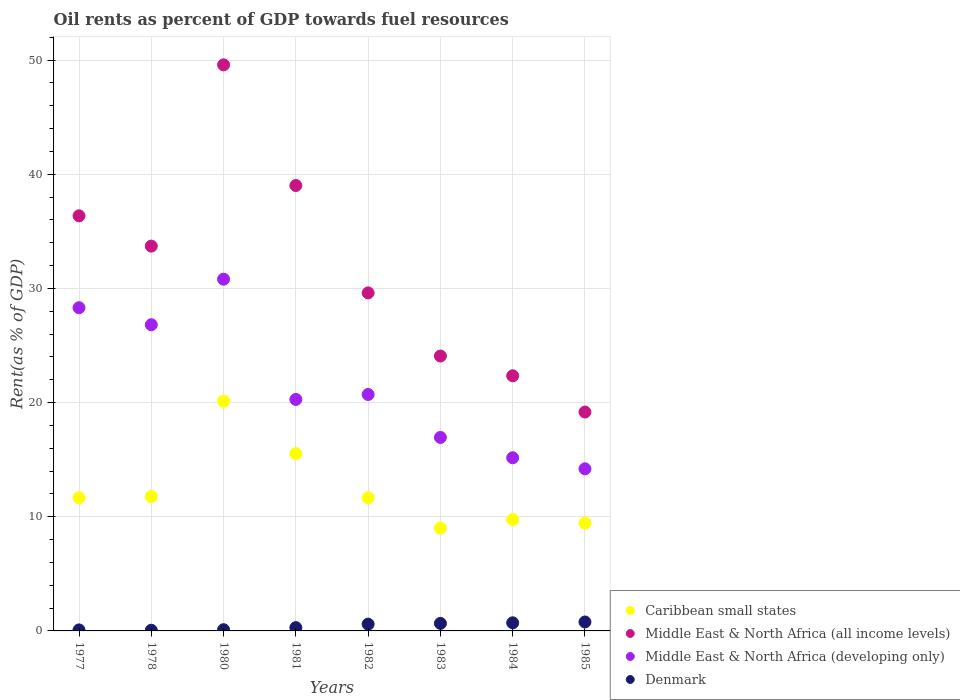Is the number of dotlines equal to the number of legend labels?
Provide a short and direct response. Yes. What is the oil rent in Caribbean small states in 1977?
Your answer should be very brief. 11.67. Across all years, what is the maximum oil rent in Caribbean small states?
Keep it short and to the point. 20.13. Across all years, what is the minimum oil rent in Caribbean small states?
Offer a very short reply. 9.01. In which year was the oil rent in Caribbean small states maximum?
Your answer should be compact. 1980. In which year was the oil rent in Caribbean small states minimum?
Provide a short and direct response. 1983. What is the total oil rent in Denmark in the graph?
Give a very brief answer. 3.29. What is the difference between the oil rent in Denmark in 1983 and that in 1984?
Your response must be concise. -0.05. What is the difference between the oil rent in Middle East & North Africa (developing only) in 1980 and the oil rent in Middle East & North Africa (all income levels) in 1977?
Your answer should be very brief. -5.55. What is the average oil rent in Middle East & North Africa (developing only) per year?
Offer a terse response. 21.66. In the year 1980, what is the difference between the oil rent in Middle East & North Africa (all income levels) and oil rent in Denmark?
Offer a very short reply. 49.48. In how many years, is the oil rent in Middle East & North Africa (all income levels) greater than 10 %?
Provide a short and direct response. 8. What is the ratio of the oil rent in Middle East & North Africa (developing only) in 1978 to that in 1980?
Your answer should be very brief. 0.87. What is the difference between the highest and the second highest oil rent in Middle East & North Africa (all income levels)?
Ensure brevity in your answer.  10.57. What is the difference between the highest and the lowest oil rent in Caribbean small states?
Your answer should be compact. 11.12. Is the sum of the oil rent in Caribbean small states in 1980 and 1984 greater than the maximum oil rent in Middle East & North Africa (all income levels) across all years?
Provide a succinct answer. No. Does the oil rent in Middle East & North Africa (developing only) monotonically increase over the years?
Provide a succinct answer. No. Is the oil rent in Caribbean small states strictly less than the oil rent in Middle East & North Africa (all income levels) over the years?
Provide a short and direct response. Yes. How many dotlines are there?
Give a very brief answer. 4. How many years are there in the graph?
Ensure brevity in your answer.  8. Are the values on the major ticks of Y-axis written in scientific E-notation?
Your response must be concise. No. Does the graph contain grids?
Provide a short and direct response. Yes. How are the legend labels stacked?
Give a very brief answer. Vertical. What is the title of the graph?
Ensure brevity in your answer.  Oil rents as percent of GDP towards fuel resources. Does "Chile" appear as one of the legend labels in the graph?
Your answer should be very brief. No. What is the label or title of the X-axis?
Ensure brevity in your answer.  Years. What is the label or title of the Y-axis?
Your response must be concise. Rent(as % of GDP). What is the Rent(as % of GDP) of Caribbean small states in 1977?
Ensure brevity in your answer.  11.67. What is the Rent(as % of GDP) of Middle East & North Africa (all income levels) in 1977?
Ensure brevity in your answer.  36.36. What is the Rent(as % of GDP) in Middle East & North Africa (developing only) in 1977?
Offer a terse response. 28.31. What is the Rent(as % of GDP) of Denmark in 1977?
Make the answer very short. 0.09. What is the Rent(as % of GDP) in Caribbean small states in 1978?
Offer a very short reply. 11.77. What is the Rent(as % of GDP) of Middle East & North Africa (all income levels) in 1978?
Give a very brief answer. 33.71. What is the Rent(as % of GDP) of Middle East & North Africa (developing only) in 1978?
Give a very brief answer. 26.82. What is the Rent(as % of GDP) in Denmark in 1978?
Give a very brief answer. 0.06. What is the Rent(as % of GDP) in Caribbean small states in 1980?
Ensure brevity in your answer.  20.13. What is the Rent(as % of GDP) of Middle East & North Africa (all income levels) in 1980?
Your answer should be compact. 49.59. What is the Rent(as % of GDP) in Middle East & North Africa (developing only) in 1980?
Provide a short and direct response. 30.81. What is the Rent(as % of GDP) in Denmark in 1980?
Offer a terse response. 0.11. What is the Rent(as % of GDP) of Caribbean small states in 1981?
Give a very brief answer. 15.53. What is the Rent(as % of GDP) of Middle East & North Africa (all income levels) in 1981?
Offer a very short reply. 39.01. What is the Rent(as % of GDP) in Middle East & North Africa (developing only) in 1981?
Provide a short and direct response. 20.28. What is the Rent(as % of GDP) of Denmark in 1981?
Ensure brevity in your answer.  0.29. What is the Rent(as % of GDP) of Caribbean small states in 1982?
Your answer should be compact. 11.66. What is the Rent(as % of GDP) of Middle East & North Africa (all income levels) in 1982?
Provide a short and direct response. 29.61. What is the Rent(as % of GDP) of Middle East & North Africa (developing only) in 1982?
Ensure brevity in your answer.  20.71. What is the Rent(as % of GDP) of Denmark in 1982?
Give a very brief answer. 0.59. What is the Rent(as % of GDP) in Caribbean small states in 1983?
Your answer should be compact. 9.01. What is the Rent(as % of GDP) of Middle East & North Africa (all income levels) in 1983?
Provide a succinct answer. 24.08. What is the Rent(as % of GDP) in Middle East & North Africa (developing only) in 1983?
Provide a short and direct response. 16.95. What is the Rent(as % of GDP) of Denmark in 1983?
Your answer should be very brief. 0.66. What is the Rent(as % of GDP) in Caribbean small states in 1984?
Ensure brevity in your answer.  9.75. What is the Rent(as % of GDP) in Middle East & North Africa (all income levels) in 1984?
Give a very brief answer. 22.35. What is the Rent(as % of GDP) in Middle East & North Africa (developing only) in 1984?
Give a very brief answer. 15.17. What is the Rent(as % of GDP) of Denmark in 1984?
Give a very brief answer. 0.71. What is the Rent(as % of GDP) in Caribbean small states in 1985?
Keep it short and to the point. 9.45. What is the Rent(as % of GDP) of Middle East & North Africa (all income levels) in 1985?
Provide a succinct answer. 19.17. What is the Rent(as % of GDP) in Middle East & North Africa (developing only) in 1985?
Your answer should be compact. 14.2. What is the Rent(as % of GDP) in Denmark in 1985?
Provide a succinct answer. 0.78. Across all years, what is the maximum Rent(as % of GDP) of Caribbean small states?
Provide a succinct answer. 20.13. Across all years, what is the maximum Rent(as % of GDP) of Middle East & North Africa (all income levels)?
Your answer should be compact. 49.59. Across all years, what is the maximum Rent(as % of GDP) of Middle East & North Africa (developing only)?
Offer a very short reply. 30.81. Across all years, what is the maximum Rent(as % of GDP) of Denmark?
Make the answer very short. 0.78. Across all years, what is the minimum Rent(as % of GDP) of Caribbean small states?
Offer a terse response. 9.01. Across all years, what is the minimum Rent(as % of GDP) in Middle East & North Africa (all income levels)?
Provide a short and direct response. 19.17. Across all years, what is the minimum Rent(as % of GDP) in Middle East & North Africa (developing only)?
Your response must be concise. 14.2. Across all years, what is the minimum Rent(as % of GDP) in Denmark?
Your response must be concise. 0.06. What is the total Rent(as % of GDP) of Caribbean small states in the graph?
Give a very brief answer. 98.97. What is the total Rent(as % of GDP) in Middle East & North Africa (all income levels) in the graph?
Your answer should be compact. 253.88. What is the total Rent(as % of GDP) in Middle East & North Africa (developing only) in the graph?
Offer a terse response. 173.25. What is the total Rent(as % of GDP) of Denmark in the graph?
Provide a succinct answer. 3.29. What is the difference between the Rent(as % of GDP) of Caribbean small states in 1977 and that in 1978?
Keep it short and to the point. -0.1. What is the difference between the Rent(as % of GDP) of Middle East & North Africa (all income levels) in 1977 and that in 1978?
Offer a terse response. 2.65. What is the difference between the Rent(as % of GDP) of Middle East & North Africa (developing only) in 1977 and that in 1978?
Ensure brevity in your answer.  1.49. What is the difference between the Rent(as % of GDP) in Denmark in 1977 and that in 1978?
Provide a succinct answer. 0.03. What is the difference between the Rent(as % of GDP) in Caribbean small states in 1977 and that in 1980?
Offer a terse response. -8.46. What is the difference between the Rent(as % of GDP) in Middle East & North Africa (all income levels) in 1977 and that in 1980?
Keep it short and to the point. -13.22. What is the difference between the Rent(as % of GDP) of Middle East & North Africa (developing only) in 1977 and that in 1980?
Ensure brevity in your answer.  -2.5. What is the difference between the Rent(as % of GDP) of Denmark in 1977 and that in 1980?
Offer a terse response. -0.02. What is the difference between the Rent(as % of GDP) of Caribbean small states in 1977 and that in 1981?
Your answer should be compact. -3.86. What is the difference between the Rent(as % of GDP) of Middle East & North Africa (all income levels) in 1977 and that in 1981?
Offer a very short reply. -2.65. What is the difference between the Rent(as % of GDP) of Middle East & North Africa (developing only) in 1977 and that in 1981?
Make the answer very short. 8.03. What is the difference between the Rent(as % of GDP) in Denmark in 1977 and that in 1981?
Offer a very short reply. -0.2. What is the difference between the Rent(as % of GDP) of Middle East & North Africa (all income levels) in 1977 and that in 1982?
Provide a succinct answer. 6.75. What is the difference between the Rent(as % of GDP) of Middle East & North Africa (developing only) in 1977 and that in 1982?
Give a very brief answer. 7.6. What is the difference between the Rent(as % of GDP) in Denmark in 1977 and that in 1982?
Keep it short and to the point. -0.51. What is the difference between the Rent(as % of GDP) in Caribbean small states in 1977 and that in 1983?
Provide a short and direct response. 2.66. What is the difference between the Rent(as % of GDP) in Middle East & North Africa (all income levels) in 1977 and that in 1983?
Your response must be concise. 12.28. What is the difference between the Rent(as % of GDP) of Middle East & North Africa (developing only) in 1977 and that in 1983?
Provide a succinct answer. 11.36. What is the difference between the Rent(as % of GDP) in Denmark in 1977 and that in 1983?
Your answer should be very brief. -0.57. What is the difference between the Rent(as % of GDP) in Caribbean small states in 1977 and that in 1984?
Keep it short and to the point. 1.92. What is the difference between the Rent(as % of GDP) of Middle East & North Africa (all income levels) in 1977 and that in 1984?
Offer a terse response. 14.01. What is the difference between the Rent(as % of GDP) in Middle East & North Africa (developing only) in 1977 and that in 1984?
Offer a terse response. 13.14. What is the difference between the Rent(as % of GDP) in Denmark in 1977 and that in 1984?
Provide a succinct answer. -0.62. What is the difference between the Rent(as % of GDP) of Caribbean small states in 1977 and that in 1985?
Give a very brief answer. 2.22. What is the difference between the Rent(as % of GDP) in Middle East & North Africa (all income levels) in 1977 and that in 1985?
Offer a terse response. 17.19. What is the difference between the Rent(as % of GDP) in Middle East & North Africa (developing only) in 1977 and that in 1985?
Your answer should be very brief. 14.11. What is the difference between the Rent(as % of GDP) of Denmark in 1977 and that in 1985?
Keep it short and to the point. -0.69. What is the difference between the Rent(as % of GDP) in Caribbean small states in 1978 and that in 1980?
Your answer should be very brief. -8.35. What is the difference between the Rent(as % of GDP) of Middle East & North Africa (all income levels) in 1978 and that in 1980?
Provide a succinct answer. -15.88. What is the difference between the Rent(as % of GDP) of Middle East & North Africa (developing only) in 1978 and that in 1980?
Provide a short and direct response. -3.99. What is the difference between the Rent(as % of GDP) of Denmark in 1978 and that in 1980?
Give a very brief answer. -0.05. What is the difference between the Rent(as % of GDP) in Caribbean small states in 1978 and that in 1981?
Keep it short and to the point. -3.75. What is the difference between the Rent(as % of GDP) of Middle East & North Africa (all income levels) in 1978 and that in 1981?
Offer a very short reply. -5.31. What is the difference between the Rent(as % of GDP) of Middle East & North Africa (developing only) in 1978 and that in 1981?
Make the answer very short. 6.54. What is the difference between the Rent(as % of GDP) of Denmark in 1978 and that in 1981?
Offer a very short reply. -0.23. What is the difference between the Rent(as % of GDP) in Caribbean small states in 1978 and that in 1982?
Make the answer very short. 0.11. What is the difference between the Rent(as % of GDP) of Middle East & North Africa (all income levels) in 1978 and that in 1982?
Your answer should be compact. 4.1. What is the difference between the Rent(as % of GDP) of Middle East & North Africa (developing only) in 1978 and that in 1982?
Provide a short and direct response. 6.11. What is the difference between the Rent(as % of GDP) in Denmark in 1978 and that in 1982?
Provide a succinct answer. -0.53. What is the difference between the Rent(as % of GDP) of Caribbean small states in 1978 and that in 1983?
Offer a very short reply. 2.77. What is the difference between the Rent(as % of GDP) of Middle East & North Africa (all income levels) in 1978 and that in 1983?
Give a very brief answer. 9.63. What is the difference between the Rent(as % of GDP) of Middle East & North Africa (developing only) in 1978 and that in 1983?
Provide a short and direct response. 9.87. What is the difference between the Rent(as % of GDP) in Denmark in 1978 and that in 1983?
Your answer should be compact. -0.6. What is the difference between the Rent(as % of GDP) of Caribbean small states in 1978 and that in 1984?
Your answer should be compact. 2.02. What is the difference between the Rent(as % of GDP) of Middle East & North Africa (all income levels) in 1978 and that in 1984?
Ensure brevity in your answer.  11.36. What is the difference between the Rent(as % of GDP) of Middle East & North Africa (developing only) in 1978 and that in 1984?
Provide a succinct answer. 11.65. What is the difference between the Rent(as % of GDP) of Denmark in 1978 and that in 1984?
Your answer should be compact. -0.65. What is the difference between the Rent(as % of GDP) of Caribbean small states in 1978 and that in 1985?
Provide a short and direct response. 2.33. What is the difference between the Rent(as % of GDP) of Middle East & North Africa (all income levels) in 1978 and that in 1985?
Ensure brevity in your answer.  14.53. What is the difference between the Rent(as % of GDP) in Middle East & North Africa (developing only) in 1978 and that in 1985?
Your answer should be compact. 12.62. What is the difference between the Rent(as % of GDP) of Denmark in 1978 and that in 1985?
Offer a very short reply. -0.72. What is the difference between the Rent(as % of GDP) in Caribbean small states in 1980 and that in 1981?
Keep it short and to the point. 4.6. What is the difference between the Rent(as % of GDP) in Middle East & North Africa (all income levels) in 1980 and that in 1981?
Offer a terse response. 10.57. What is the difference between the Rent(as % of GDP) in Middle East & North Africa (developing only) in 1980 and that in 1981?
Give a very brief answer. 10.53. What is the difference between the Rent(as % of GDP) in Denmark in 1980 and that in 1981?
Your answer should be very brief. -0.18. What is the difference between the Rent(as % of GDP) in Caribbean small states in 1980 and that in 1982?
Provide a succinct answer. 8.47. What is the difference between the Rent(as % of GDP) of Middle East & North Africa (all income levels) in 1980 and that in 1982?
Give a very brief answer. 19.98. What is the difference between the Rent(as % of GDP) of Middle East & North Africa (developing only) in 1980 and that in 1982?
Make the answer very short. 10.1. What is the difference between the Rent(as % of GDP) in Denmark in 1980 and that in 1982?
Your answer should be very brief. -0.49. What is the difference between the Rent(as % of GDP) in Caribbean small states in 1980 and that in 1983?
Give a very brief answer. 11.12. What is the difference between the Rent(as % of GDP) of Middle East & North Africa (all income levels) in 1980 and that in 1983?
Provide a succinct answer. 25.51. What is the difference between the Rent(as % of GDP) of Middle East & North Africa (developing only) in 1980 and that in 1983?
Offer a very short reply. 13.86. What is the difference between the Rent(as % of GDP) in Denmark in 1980 and that in 1983?
Offer a very short reply. -0.55. What is the difference between the Rent(as % of GDP) in Caribbean small states in 1980 and that in 1984?
Make the answer very short. 10.38. What is the difference between the Rent(as % of GDP) of Middle East & North Africa (all income levels) in 1980 and that in 1984?
Keep it short and to the point. 27.24. What is the difference between the Rent(as % of GDP) of Middle East & North Africa (developing only) in 1980 and that in 1984?
Make the answer very short. 15.64. What is the difference between the Rent(as % of GDP) of Denmark in 1980 and that in 1984?
Your answer should be compact. -0.6. What is the difference between the Rent(as % of GDP) in Caribbean small states in 1980 and that in 1985?
Give a very brief answer. 10.68. What is the difference between the Rent(as % of GDP) in Middle East & North Africa (all income levels) in 1980 and that in 1985?
Give a very brief answer. 30.41. What is the difference between the Rent(as % of GDP) of Middle East & North Africa (developing only) in 1980 and that in 1985?
Your answer should be compact. 16.61. What is the difference between the Rent(as % of GDP) in Denmark in 1980 and that in 1985?
Keep it short and to the point. -0.68. What is the difference between the Rent(as % of GDP) of Caribbean small states in 1981 and that in 1982?
Your answer should be very brief. 3.87. What is the difference between the Rent(as % of GDP) of Middle East & North Africa (all income levels) in 1981 and that in 1982?
Make the answer very short. 9.4. What is the difference between the Rent(as % of GDP) of Middle East & North Africa (developing only) in 1981 and that in 1982?
Provide a short and direct response. -0.43. What is the difference between the Rent(as % of GDP) in Denmark in 1981 and that in 1982?
Provide a succinct answer. -0.3. What is the difference between the Rent(as % of GDP) in Caribbean small states in 1981 and that in 1983?
Offer a terse response. 6.52. What is the difference between the Rent(as % of GDP) in Middle East & North Africa (all income levels) in 1981 and that in 1983?
Your answer should be compact. 14.93. What is the difference between the Rent(as % of GDP) of Middle East & North Africa (developing only) in 1981 and that in 1983?
Give a very brief answer. 3.33. What is the difference between the Rent(as % of GDP) in Denmark in 1981 and that in 1983?
Keep it short and to the point. -0.37. What is the difference between the Rent(as % of GDP) in Caribbean small states in 1981 and that in 1984?
Keep it short and to the point. 5.77. What is the difference between the Rent(as % of GDP) in Middle East & North Africa (all income levels) in 1981 and that in 1984?
Provide a succinct answer. 16.67. What is the difference between the Rent(as % of GDP) of Middle East & North Africa (developing only) in 1981 and that in 1984?
Provide a succinct answer. 5.11. What is the difference between the Rent(as % of GDP) of Denmark in 1981 and that in 1984?
Keep it short and to the point. -0.42. What is the difference between the Rent(as % of GDP) in Caribbean small states in 1981 and that in 1985?
Give a very brief answer. 6.08. What is the difference between the Rent(as % of GDP) of Middle East & North Africa (all income levels) in 1981 and that in 1985?
Ensure brevity in your answer.  19.84. What is the difference between the Rent(as % of GDP) of Middle East & North Africa (developing only) in 1981 and that in 1985?
Your response must be concise. 6.08. What is the difference between the Rent(as % of GDP) in Denmark in 1981 and that in 1985?
Your answer should be very brief. -0.49. What is the difference between the Rent(as % of GDP) in Caribbean small states in 1982 and that in 1983?
Offer a very short reply. 2.65. What is the difference between the Rent(as % of GDP) in Middle East & North Africa (all income levels) in 1982 and that in 1983?
Ensure brevity in your answer.  5.53. What is the difference between the Rent(as % of GDP) of Middle East & North Africa (developing only) in 1982 and that in 1983?
Keep it short and to the point. 3.76. What is the difference between the Rent(as % of GDP) of Denmark in 1982 and that in 1983?
Give a very brief answer. -0.07. What is the difference between the Rent(as % of GDP) of Caribbean small states in 1982 and that in 1984?
Keep it short and to the point. 1.91. What is the difference between the Rent(as % of GDP) of Middle East & North Africa (all income levels) in 1982 and that in 1984?
Ensure brevity in your answer.  7.26. What is the difference between the Rent(as % of GDP) of Middle East & North Africa (developing only) in 1982 and that in 1984?
Ensure brevity in your answer.  5.54. What is the difference between the Rent(as % of GDP) of Denmark in 1982 and that in 1984?
Ensure brevity in your answer.  -0.12. What is the difference between the Rent(as % of GDP) of Caribbean small states in 1982 and that in 1985?
Ensure brevity in your answer.  2.21. What is the difference between the Rent(as % of GDP) of Middle East & North Africa (all income levels) in 1982 and that in 1985?
Ensure brevity in your answer.  10.44. What is the difference between the Rent(as % of GDP) of Middle East & North Africa (developing only) in 1982 and that in 1985?
Your answer should be very brief. 6.51. What is the difference between the Rent(as % of GDP) of Denmark in 1982 and that in 1985?
Keep it short and to the point. -0.19. What is the difference between the Rent(as % of GDP) of Caribbean small states in 1983 and that in 1984?
Your response must be concise. -0.75. What is the difference between the Rent(as % of GDP) in Middle East & North Africa (all income levels) in 1983 and that in 1984?
Your response must be concise. 1.73. What is the difference between the Rent(as % of GDP) of Middle East & North Africa (developing only) in 1983 and that in 1984?
Offer a very short reply. 1.78. What is the difference between the Rent(as % of GDP) in Denmark in 1983 and that in 1984?
Make the answer very short. -0.05. What is the difference between the Rent(as % of GDP) in Caribbean small states in 1983 and that in 1985?
Provide a succinct answer. -0.44. What is the difference between the Rent(as % of GDP) of Middle East & North Africa (all income levels) in 1983 and that in 1985?
Keep it short and to the point. 4.91. What is the difference between the Rent(as % of GDP) in Middle East & North Africa (developing only) in 1983 and that in 1985?
Your answer should be very brief. 2.75. What is the difference between the Rent(as % of GDP) in Denmark in 1983 and that in 1985?
Offer a very short reply. -0.12. What is the difference between the Rent(as % of GDP) of Caribbean small states in 1984 and that in 1985?
Keep it short and to the point. 0.31. What is the difference between the Rent(as % of GDP) in Middle East & North Africa (all income levels) in 1984 and that in 1985?
Give a very brief answer. 3.18. What is the difference between the Rent(as % of GDP) of Middle East & North Africa (developing only) in 1984 and that in 1985?
Offer a terse response. 0.97. What is the difference between the Rent(as % of GDP) of Denmark in 1984 and that in 1985?
Keep it short and to the point. -0.07. What is the difference between the Rent(as % of GDP) of Caribbean small states in 1977 and the Rent(as % of GDP) of Middle East & North Africa (all income levels) in 1978?
Provide a short and direct response. -22.04. What is the difference between the Rent(as % of GDP) in Caribbean small states in 1977 and the Rent(as % of GDP) in Middle East & North Africa (developing only) in 1978?
Keep it short and to the point. -15.15. What is the difference between the Rent(as % of GDP) of Caribbean small states in 1977 and the Rent(as % of GDP) of Denmark in 1978?
Keep it short and to the point. 11.61. What is the difference between the Rent(as % of GDP) of Middle East & North Africa (all income levels) in 1977 and the Rent(as % of GDP) of Middle East & North Africa (developing only) in 1978?
Provide a succinct answer. 9.54. What is the difference between the Rent(as % of GDP) in Middle East & North Africa (all income levels) in 1977 and the Rent(as % of GDP) in Denmark in 1978?
Make the answer very short. 36.3. What is the difference between the Rent(as % of GDP) of Middle East & North Africa (developing only) in 1977 and the Rent(as % of GDP) of Denmark in 1978?
Ensure brevity in your answer.  28.25. What is the difference between the Rent(as % of GDP) of Caribbean small states in 1977 and the Rent(as % of GDP) of Middle East & North Africa (all income levels) in 1980?
Your answer should be compact. -37.92. What is the difference between the Rent(as % of GDP) of Caribbean small states in 1977 and the Rent(as % of GDP) of Middle East & North Africa (developing only) in 1980?
Offer a terse response. -19.14. What is the difference between the Rent(as % of GDP) of Caribbean small states in 1977 and the Rent(as % of GDP) of Denmark in 1980?
Keep it short and to the point. 11.56. What is the difference between the Rent(as % of GDP) in Middle East & North Africa (all income levels) in 1977 and the Rent(as % of GDP) in Middle East & North Africa (developing only) in 1980?
Your response must be concise. 5.55. What is the difference between the Rent(as % of GDP) in Middle East & North Africa (all income levels) in 1977 and the Rent(as % of GDP) in Denmark in 1980?
Give a very brief answer. 36.25. What is the difference between the Rent(as % of GDP) of Middle East & North Africa (developing only) in 1977 and the Rent(as % of GDP) of Denmark in 1980?
Your answer should be very brief. 28.2. What is the difference between the Rent(as % of GDP) of Caribbean small states in 1977 and the Rent(as % of GDP) of Middle East & North Africa (all income levels) in 1981?
Your response must be concise. -27.34. What is the difference between the Rent(as % of GDP) in Caribbean small states in 1977 and the Rent(as % of GDP) in Middle East & North Africa (developing only) in 1981?
Your answer should be very brief. -8.61. What is the difference between the Rent(as % of GDP) in Caribbean small states in 1977 and the Rent(as % of GDP) in Denmark in 1981?
Offer a very short reply. 11.38. What is the difference between the Rent(as % of GDP) in Middle East & North Africa (all income levels) in 1977 and the Rent(as % of GDP) in Middle East & North Africa (developing only) in 1981?
Your response must be concise. 16.08. What is the difference between the Rent(as % of GDP) in Middle East & North Africa (all income levels) in 1977 and the Rent(as % of GDP) in Denmark in 1981?
Offer a terse response. 36.07. What is the difference between the Rent(as % of GDP) in Middle East & North Africa (developing only) in 1977 and the Rent(as % of GDP) in Denmark in 1981?
Provide a short and direct response. 28.02. What is the difference between the Rent(as % of GDP) of Caribbean small states in 1977 and the Rent(as % of GDP) of Middle East & North Africa (all income levels) in 1982?
Provide a short and direct response. -17.94. What is the difference between the Rent(as % of GDP) in Caribbean small states in 1977 and the Rent(as % of GDP) in Middle East & North Africa (developing only) in 1982?
Keep it short and to the point. -9.04. What is the difference between the Rent(as % of GDP) of Caribbean small states in 1977 and the Rent(as % of GDP) of Denmark in 1982?
Make the answer very short. 11.08. What is the difference between the Rent(as % of GDP) in Middle East & North Africa (all income levels) in 1977 and the Rent(as % of GDP) in Middle East & North Africa (developing only) in 1982?
Offer a terse response. 15.65. What is the difference between the Rent(as % of GDP) in Middle East & North Africa (all income levels) in 1977 and the Rent(as % of GDP) in Denmark in 1982?
Your answer should be very brief. 35.77. What is the difference between the Rent(as % of GDP) in Middle East & North Africa (developing only) in 1977 and the Rent(as % of GDP) in Denmark in 1982?
Your answer should be compact. 27.72. What is the difference between the Rent(as % of GDP) in Caribbean small states in 1977 and the Rent(as % of GDP) in Middle East & North Africa (all income levels) in 1983?
Keep it short and to the point. -12.41. What is the difference between the Rent(as % of GDP) of Caribbean small states in 1977 and the Rent(as % of GDP) of Middle East & North Africa (developing only) in 1983?
Ensure brevity in your answer.  -5.28. What is the difference between the Rent(as % of GDP) in Caribbean small states in 1977 and the Rent(as % of GDP) in Denmark in 1983?
Your answer should be compact. 11.01. What is the difference between the Rent(as % of GDP) of Middle East & North Africa (all income levels) in 1977 and the Rent(as % of GDP) of Middle East & North Africa (developing only) in 1983?
Provide a short and direct response. 19.41. What is the difference between the Rent(as % of GDP) of Middle East & North Africa (all income levels) in 1977 and the Rent(as % of GDP) of Denmark in 1983?
Provide a succinct answer. 35.7. What is the difference between the Rent(as % of GDP) in Middle East & North Africa (developing only) in 1977 and the Rent(as % of GDP) in Denmark in 1983?
Your answer should be compact. 27.65. What is the difference between the Rent(as % of GDP) in Caribbean small states in 1977 and the Rent(as % of GDP) in Middle East & North Africa (all income levels) in 1984?
Your answer should be compact. -10.68. What is the difference between the Rent(as % of GDP) in Caribbean small states in 1977 and the Rent(as % of GDP) in Middle East & North Africa (developing only) in 1984?
Provide a succinct answer. -3.5. What is the difference between the Rent(as % of GDP) in Caribbean small states in 1977 and the Rent(as % of GDP) in Denmark in 1984?
Provide a short and direct response. 10.96. What is the difference between the Rent(as % of GDP) of Middle East & North Africa (all income levels) in 1977 and the Rent(as % of GDP) of Middle East & North Africa (developing only) in 1984?
Offer a terse response. 21.19. What is the difference between the Rent(as % of GDP) of Middle East & North Africa (all income levels) in 1977 and the Rent(as % of GDP) of Denmark in 1984?
Give a very brief answer. 35.65. What is the difference between the Rent(as % of GDP) of Middle East & North Africa (developing only) in 1977 and the Rent(as % of GDP) of Denmark in 1984?
Offer a terse response. 27.6. What is the difference between the Rent(as % of GDP) of Caribbean small states in 1977 and the Rent(as % of GDP) of Middle East & North Africa (all income levels) in 1985?
Provide a succinct answer. -7.5. What is the difference between the Rent(as % of GDP) of Caribbean small states in 1977 and the Rent(as % of GDP) of Middle East & North Africa (developing only) in 1985?
Your answer should be very brief. -2.53. What is the difference between the Rent(as % of GDP) of Caribbean small states in 1977 and the Rent(as % of GDP) of Denmark in 1985?
Provide a short and direct response. 10.89. What is the difference between the Rent(as % of GDP) of Middle East & North Africa (all income levels) in 1977 and the Rent(as % of GDP) of Middle East & North Africa (developing only) in 1985?
Give a very brief answer. 22.16. What is the difference between the Rent(as % of GDP) in Middle East & North Africa (all income levels) in 1977 and the Rent(as % of GDP) in Denmark in 1985?
Keep it short and to the point. 35.58. What is the difference between the Rent(as % of GDP) in Middle East & North Africa (developing only) in 1977 and the Rent(as % of GDP) in Denmark in 1985?
Offer a very short reply. 27.53. What is the difference between the Rent(as % of GDP) in Caribbean small states in 1978 and the Rent(as % of GDP) in Middle East & North Africa (all income levels) in 1980?
Give a very brief answer. -37.81. What is the difference between the Rent(as % of GDP) of Caribbean small states in 1978 and the Rent(as % of GDP) of Middle East & North Africa (developing only) in 1980?
Offer a very short reply. -19.04. What is the difference between the Rent(as % of GDP) of Caribbean small states in 1978 and the Rent(as % of GDP) of Denmark in 1980?
Your answer should be compact. 11.67. What is the difference between the Rent(as % of GDP) in Middle East & North Africa (all income levels) in 1978 and the Rent(as % of GDP) in Middle East & North Africa (developing only) in 1980?
Your answer should be compact. 2.9. What is the difference between the Rent(as % of GDP) of Middle East & North Africa (all income levels) in 1978 and the Rent(as % of GDP) of Denmark in 1980?
Your answer should be compact. 33.6. What is the difference between the Rent(as % of GDP) in Middle East & North Africa (developing only) in 1978 and the Rent(as % of GDP) in Denmark in 1980?
Keep it short and to the point. 26.71. What is the difference between the Rent(as % of GDP) of Caribbean small states in 1978 and the Rent(as % of GDP) of Middle East & North Africa (all income levels) in 1981?
Provide a succinct answer. -27.24. What is the difference between the Rent(as % of GDP) in Caribbean small states in 1978 and the Rent(as % of GDP) in Middle East & North Africa (developing only) in 1981?
Offer a terse response. -8.5. What is the difference between the Rent(as % of GDP) in Caribbean small states in 1978 and the Rent(as % of GDP) in Denmark in 1981?
Offer a very short reply. 11.49. What is the difference between the Rent(as % of GDP) of Middle East & North Africa (all income levels) in 1978 and the Rent(as % of GDP) of Middle East & North Africa (developing only) in 1981?
Make the answer very short. 13.43. What is the difference between the Rent(as % of GDP) in Middle East & North Africa (all income levels) in 1978 and the Rent(as % of GDP) in Denmark in 1981?
Make the answer very short. 33.42. What is the difference between the Rent(as % of GDP) of Middle East & North Africa (developing only) in 1978 and the Rent(as % of GDP) of Denmark in 1981?
Ensure brevity in your answer.  26.53. What is the difference between the Rent(as % of GDP) in Caribbean small states in 1978 and the Rent(as % of GDP) in Middle East & North Africa (all income levels) in 1982?
Your answer should be compact. -17.84. What is the difference between the Rent(as % of GDP) in Caribbean small states in 1978 and the Rent(as % of GDP) in Middle East & North Africa (developing only) in 1982?
Your answer should be compact. -8.94. What is the difference between the Rent(as % of GDP) of Caribbean small states in 1978 and the Rent(as % of GDP) of Denmark in 1982?
Make the answer very short. 11.18. What is the difference between the Rent(as % of GDP) in Middle East & North Africa (all income levels) in 1978 and the Rent(as % of GDP) in Middle East & North Africa (developing only) in 1982?
Offer a very short reply. 13. What is the difference between the Rent(as % of GDP) in Middle East & North Africa (all income levels) in 1978 and the Rent(as % of GDP) in Denmark in 1982?
Make the answer very short. 33.11. What is the difference between the Rent(as % of GDP) of Middle East & North Africa (developing only) in 1978 and the Rent(as % of GDP) of Denmark in 1982?
Your response must be concise. 26.23. What is the difference between the Rent(as % of GDP) in Caribbean small states in 1978 and the Rent(as % of GDP) in Middle East & North Africa (all income levels) in 1983?
Offer a very short reply. -12.31. What is the difference between the Rent(as % of GDP) of Caribbean small states in 1978 and the Rent(as % of GDP) of Middle East & North Africa (developing only) in 1983?
Offer a terse response. -5.17. What is the difference between the Rent(as % of GDP) in Caribbean small states in 1978 and the Rent(as % of GDP) in Denmark in 1983?
Make the answer very short. 11.12. What is the difference between the Rent(as % of GDP) of Middle East & North Africa (all income levels) in 1978 and the Rent(as % of GDP) of Middle East & North Africa (developing only) in 1983?
Provide a short and direct response. 16.76. What is the difference between the Rent(as % of GDP) of Middle East & North Africa (all income levels) in 1978 and the Rent(as % of GDP) of Denmark in 1983?
Provide a succinct answer. 33.05. What is the difference between the Rent(as % of GDP) in Middle East & North Africa (developing only) in 1978 and the Rent(as % of GDP) in Denmark in 1983?
Your answer should be very brief. 26.16. What is the difference between the Rent(as % of GDP) in Caribbean small states in 1978 and the Rent(as % of GDP) in Middle East & North Africa (all income levels) in 1984?
Make the answer very short. -10.57. What is the difference between the Rent(as % of GDP) in Caribbean small states in 1978 and the Rent(as % of GDP) in Middle East & North Africa (developing only) in 1984?
Your answer should be compact. -3.39. What is the difference between the Rent(as % of GDP) in Caribbean small states in 1978 and the Rent(as % of GDP) in Denmark in 1984?
Provide a short and direct response. 11.06. What is the difference between the Rent(as % of GDP) in Middle East & North Africa (all income levels) in 1978 and the Rent(as % of GDP) in Middle East & North Africa (developing only) in 1984?
Make the answer very short. 18.54. What is the difference between the Rent(as % of GDP) of Middle East & North Africa (all income levels) in 1978 and the Rent(as % of GDP) of Denmark in 1984?
Your answer should be very brief. 33. What is the difference between the Rent(as % of GDP) in Middle East & North Africa (developing only) in 1978 and the Rent(as % of GDP) in Denmark in 1984?
Provide a short and direct response. 26.11. What is the difference between the Rent(as % of GDP) in Caribbean small states in 1978 and the Rent(as % of GDP) in Middle East & North Africa (all income levels) in 1985?
Provide a short and direct response. -7.4. What is the difference between the Rent(as % of GDP) in Caribbean small states in 1978 and the Rent(as % of GDP) in Middle East & North Africa (developing only) in 1985?
Keep it short and to the point. -2.43. What is the difference between the Rent(as % of GDP) of Caribbean small states in 1978 and the Rent(as % of GDP) of Denmark in 1985?
Keep it short and to the point. 10.99. What is the difference between the Rent(as % of GDP) in Middle East & North Africa (all income levels) in 1978 and the Rent(as % of GDP) in Middle East & North Africa (developing only) in 1985?
Provide a short and direct response. 19.51. What is the difference between the Rent(as % of GDP) in Middle East & North Africa (all income levels) in 1978 and the Rent(as % of GDP) in Denmark in 1985?
Your answer should be compact. 32.92. What is the difference between the Rent(as % of GDP) in Middle East & North Africa (developing only) in 1978 and the Rent(as % of GDP) in Denmark in 1985?
Provide a succinct answer. 26.04. What is the difference between the Rent(as % of GDP) in Caribbean small states in 1980 and the Rent(as % of GDP) in Middle East & North Africa (all income levels) in 1981?
Make the answer very short. -18.89. What is the difference between the Rent(as % of GDP) of Caribbean small states in 1980 and the Rent(as % of GDP) of Middle East & North Africa (developing only) in 1981?
Your answer should be very brief. -0.15. What is the difference between the Rent(as % of GDP) of Caribbean small states in 1980 and the Rent(as % of GDP) of Denmark in 1981?
Your response must be concise. 19.84. What is the difference between the Rent(as % of GDP) in Middle East & North Africa (all income levels) in 1980 and the Rent(as % of GDP) in Middle East & North Africa (developing only) in 1981?
Make the answer very short. 29.31. What is the difference between the Rent(as % of GDP) in Middle East & North Africa (all income levels) in 1980 and the Rent(as % of GDP) in Denmark in 1981?
Ensure brevity in your answer.  49.3. What is the difference between the Rent(as % of GDP) in Middle East & North Africa (developing only) in 1980 and the Rent(as % of GDP) in Denmark in 1981?
Your answer should be compact. 30.52. What is the difference between the Rent(as % of GDP) in Caribbean small states in 1980 and the Rent(as % of GDP) in Middle East & North Africa (all income levels) in 1982?
Offer a terse response. -9.48. What is the difference between the Rent(as % of GDP) of Caribbean small states in 1980 and the Rent(as % of GDP) of Middle East & North Africa (developing only) in 1982?
Make the answer very short. -0.58. What is the difference between the Rent(as % of GDP) of Caribbean small states in 1980 and the Rent(as % of GDP) of Denmark in 1982?
Offer a very short reply. 19.54. What is the difference between the Rent(as % of GDP) of Middle East & North Africa (all income levels) in 1980 and the Rent(as % of GDP) of Middle East & North Africa (developing only) in 1982?
Offer a very short reply. 28.88. What is the difference between the Rent(as % of GDP) in Middle East & North Africa (all income levels) in 1980 and the Rent(as % of GDP) in Denmark in 1982?
Offer a terse response. 48.99. What is the difference between the Rent(as % of GDP) of Middle East & North Africa (developing only) in 1980 and the Rent(as % of GDP) of Denmark in 1982?
Your answer should be compact. 30.22. What is the difference between the Rent(as % of GDP) in Caribbean small states in 1980 and the Rent(as % of GDP) in Middle East & North Africa (all income levels) in 1983?
Make the answer very short. -3.95. What is the difference between the Rent(as % of GDP) of Caribbean small states in 1980 and the Rent(as % of GDP) of Middle East & North Africa (developing only) in 1983?
Keep it short and to the point. 3.18. What is the difference between the Rent(as % of GDP) of Caribbean small states in 1980 and the Rent(as % of GDP) of Denmark in 1983?
Provide a succinct answer. 19.47. What is the difference between the Rent(as % of GDP) of Middle East & North Africa (all income levels) in 1980 and the Rent(as % of GDP) of Middle East & North Africa (developing only) in 1983?
Give a very brief answer. 32.64. What is the difference between the Rent(as % of GDP) of Middle East & North Africa (all income levels) in 1980 and the Rent(as % of GDP) of Denmark in 1983?
Keep it short and to the point. 48.93. What is the difference between the Rent(as % of GDP) in Middle East & North Africa (developing only) in 1980 and the Rent(as % of GDP) in Denmark in 1983?
Keep it short and to the point. 30.15. What is the difference between the Rent(as % of GDP) of Caribbean small states in 1980 and the Rent(as % of GDP) of Middle East & North Africa (all income levels) in 1984?
Your response must be concise. -2.22. What is the difference between the Rent(as % of GDP) of Caribbean small states in 1980 and the Rent(as % of GDP) of Middle East & North Africa (developing only) in 1984?
Provide a short and direct response. 4.96. What is the difference between the Rent(as % of GDP) of Caribbean small states in 1980 and the Rent(as % of GDP) of Denmark in 1984?
Your answer should be compact. 19.42. What is the difference between the Rent(as % of GDP) in Middle East & North Africa (all income levels) in 1980 and the Rent(as % of GDP) in Middle East & North Africa (developing only) in 1984?
Your response must be concise. 34.42. What is the difference between the Rent(as % of GDP) of Middle East & North Africa (all income levels) in 1980 and the Rent(as % of GDP) of Denmark in 1984?
Offer a terse response. 48.88. What is the difference between the Rent(as % of GDP) in Middle East & North Africa (developing only) in 1980 and the Rent(as % of GDP) in Denmark in 1984?
Offer a very short reply. 30.1. What is the difference between the Rent(as % of GDP) in Caribbean small states in 1980 and the Rent(as % of GDP) in Middle East & North Africa (all income levels) in 1985?
Make the answer very short. 0.96. What is the difference between the Rent(as % of GDP) of Caribbean small states in 1980 and the Rent(as % of GDP) of Middle East & North Africa (developing only) in 1985?
Offer a very short reply. 5.93. What is the difference between the Rent(as % of GDP) of Caribbean small states in 1980 and the Rent(as % of GDP) of Denmark in 1985?
Provide a succinct answer. 19.35. What is the difference between the Rent(as % of GDP) in Middle East & North Africa (all income levels) in 1980 and the Rent(as % of GDP) in Middle East & North Africa (developing only) in 1985?
Offer a terse response. 35.39. What is the difference between the Rent(as % of GDP) in Middle East & North Africa (all income levels) in 1980 and the Rent(as % of GDP) in Denmark in 1985?
Keep it short and to the point. 48.8. What is the difference between the Rent(as % of GDP) of Middle East & North Africa (developing only) in 1980 and the Rent(as % of GDP) of Denmark in 1985?
Make the answer very short. 30.03. What is the difference between the Rent(as % of GDP) of Caribbean small states in 1981 and the Rent(as % of GDP) of Middle East & North Africa (all income levels) in 1982?
Provide a succinct answer. -14.08. What is the difference between the Rent(as % of GDP) of Caribbean small states in 1981 and the Rent(as % of GDP) of Middle East & North Africa (developing only) in 1982?
Offer a very short reply. -5.18. What is the difference between the Rent(as % of GDP) of Caribbean small states in 1981 and the Rent(as % of GDP) of Denmark in 1982?
Keep it short and to the point. 14.93. What is the difference between the Rent(as % of GDP) in Middle East & North Africa (all income levels) in 1981 and the Rent(as % of GDP) in Middle East & North Africa (developing only) in 1982?
Keep it short and to the point. 18.3. What is the difference between the Rent(as % of GDP) in Middle East & North Africa (all income levels) in 1981 and the Rent(as % of GDP) in Denmark in 1982?
Your answer should be compact. 38.42. What is the difference between the Rent(as % of GDP) of Middle East & North Africa (developing only) in 1981 and the Rent(as % of GDP) of Denmark in 1982?
Make the answer very short. 19.68. What is the difference between the Rent(as % of GDP) in Caribbean small states in 1981 and the Rent(as % of GDP) in Middle East & North Africa (all income levels) in 1983?
Your answer should be very brief. -8.55. What is the difference between the Rent(as % of GDP) of Caribbean small states in 1981 and the Rent(as % of GDP) of Middle East & North Africa (developing only) in 1983?
Make the answer very short. -1.42. What is the difference between the Rent(as % of GDP) of Caribbean small states in 1981 and the Rent(as % of GDP) of Denmark in 1983?
Ensure brevity in your answer.  14.87. What is the difference between the Rent(as % of GDP) of Middle East & North Africa (all income levels) in 1981 and the Rent(as % of GDP) of Middle East & North Africa (developing only) in 1983?
Your answer should be compact. 22.07. What is the difference between the Rent(as % of GDP) in Middle East & North Africa (all income levels) in 1981 and the Rent(as % of GDP) in Denmark in 1983?
Provide a succinct answer. 38.36. What is the difference between the Rent(as % of GDP) in Middle East & North Africa (developing only) in 1981 and the Rent(as % of GDP) in Denmark in 1983?
Your answer should be very brief. 19.62. What is the difference between the Rent(as % of GDP) in Caribbean small states in 1981 and the Rent(as % of GDP) in Middle East & North Africa (all income levels) in 1984?
Offer a terse response. -6.82. What is the difference between the Rent(as % of GDP) of Caribbean small states in 1981 and the Rent(as % of GDP) of Middle East & North Africa (developing only) in 1984?
Offer a very short reply. 0.36. What is the difference between the Rent(as % of GDP) in Caribbean small states in 1981 and the Rent(as % of GDP) in Denmark in 1984?
Provide a short and direct response. 14.82. What is the difference between the Rent(as % of GDP) of Middle East & North Africa (all income levels) in 1981 and the Rent(as % of GDP) of Middle East & North Africa (developing only) in 1984?
Offer a very short reply. 23.85. What is the difference between the Rent(as % of GDP) in Middle East & North Africa (all income levels) in 1981 and the Rent(as % of GDP) in Denmark in 1984?
Keep it short and to the point. 38.3. What is the difference between the Rent(as % of GDP) of Middle East & North Africa (developing only) in 1981 and the Rent(as % of GDP) of Denmark in 1984?
Offer a very short reply. 19.57. What is the difference between the Rent(as % of GDP) in Caribbean small states in 1981 and the Rent(as % of GDP) in Middle East & North Africa (all income levels) in 1985?
Your answer should be compact. -3.65. What is the difference between the Rent(as % of GDP) in Caribbean small states in 1981 and the Rent(as % of GDP) in Middle East & North Africa (developing only) in 1985?
Your answer should be compact. 1.33. What is the difference between the Rent(as % of GDP) of Caribbean small states in 1981 and the Rent(as % of GDP) of Denmark in 1985?
Give a very brief answer. 14.74. What is the difference between the Rent(as % of GDP) of Middle East & North Africa (all income levels) in 1981 and the Rent(as % of GDP) of Middle East & North Africa (developing only) in 1985?
Provide a short and direct response. 24.81. What is the difference between the Rent(as % of GDP) in Middle East & North Africa (all income levels) in 1981 and the Rent(as % of GDP) in Denmark in 1985?
Provide a succinct answer. 38.23. What is the difference between the Rent(as % of GDP) in Middle East & North Africa (developing only) in 1981 and the Rent(as % of GDP) in Denmark in 1985?
Provide a short and direct response. 19.49. What is the difference between the Rent(as % of GDP) in Caribbean small states in 1982 and the Rent(as % of GDP) in Middle East & North Africa (all income levels) in 1983?
Provide a succinct answer. -12.42. What is the difference between the Rent(as % of GDP) in Caribbean small states in 1982 and the Rent(as % of GDP) in Middle East & North Africa (developing only) in 1983?
Give a very brief answer. -5.29. What is the difference between the Rent(as % of GDP) in Caribbean small states in 1982 and the Rent(as % of GDP) in Denmark in 1983?
Offer a terse response. 11. What is the difference between the Rent(as % of GDP) in Middle East & North Africa (all income levels) in 1982 and the Rent(as % of GDP) in Middle East & North Africa (developing only) in 1983?
Keep it short and to the point. 12.66. What is the difference between the Rent(as % of GDP) in Middle East & North Africa (all income levels) in 1982 and the Rent(as % of GDP) in Denmark in 1983?
Provide a succinct answer. 28.95. What is the difference between the Rent(as % of GDP) of Middle East & North Africa (developing only) in 1982 and the Rent(as % of GDP) of Denmark in 1983?
Your answer should be very brief. 20.05. What is the difference between the Rent(as % of GDP) of Caribbean small states in 1982 and the Rent(as % of GDP) of Middle East & North Africa (all income levels) in 1984?
Offer a terse response. -10.69. What is the difference between the Rent(as % of GDP) of Caribbean small states in 1982 and the Rent(as % of GDP) of Middle East & North Africa (developing only) in 1984?
Your response must be concise. -3.51. What is the difference between the Rent(as % of GDP) of Caribbean small states in 1982 and the Rent(as % of GDP) of Denmark in 1984?
Provide a succinct answer. 10.95. What is the difference between the Rent(as % of GDP) of Middle East & North Africa (all income levels) in 1982 and the Rent(as % of GDP) of Middle East & North Africa (developing only) in 1984?
Your response must be concise. 14.44. What is the difference between the Rent(as % of GDP) in Middle East & North Africa (all income levels) in 1982 and the Rent(as % of GDP) in Denmark in 1984?
Your answer should be compact. 28.9. What is the difference between the Rent(as % of GDP) in Middle East & North Africa (developing only) in 1982 and the Rent(as % of GDP) in Denmark in 1984?
Provide a short and direct response. 20. What is the difference between the Rent(as % of GDP) in Caribbean small states in 1982 and the Rent(as % of GDP) in Middle East & North Africa (all income levels) in 1985?
Your answer should be very brief. -7.51. What is the difference between the Rent(as % of GDP) in Caribbean small states in 1982 and the Rent(as % of GDP) in Middle East & North Africa (developing only) in 1985?
Provide a succinct answer. -2.54. What is the difference between the Rent(as % of GDP) in Caribbean small states in 1982 and the Rent(as % of GDP) in Denmark in 1985?
Make the answer very short. 10.88. What is the difference between the Rent(as % of GDP) in Middle East & North Africa (all income levels) in 1982 and the Rent(as % of GDP) in Middle East & North Africa (developing only) in 1985?
Offer a very short reply. 15.41. What is the difference between the Rent(as % of GDP) in Middle East & North Africa (all income levels) in 1982 and the Rent(as % of GDP) in Denmark in 1985?
Your answer should be compact. 28.83. What is the difference between the Rent(as % of GDP) of Middle East & North Africa (developing only) in 1982 and the Rent(as % of GDP) of Denmark in 1985?
Your answer should be compact. 19.93. What is the difference between the Rent(as % of GDP) in Caribbean small states in 1983 and the Rent(as % of GDP) in Middle East & North Africa (all income levels) in 1984?
Make the answer very short. -13.34. What is the difference between the Rent(as % of GDP) in Caribbean small states in 1983 and the Rent(as % of GDP) in Middle East & North Africa (developing only) in 1984?
Your answer should be very brief. -6.16. What is the difference between the Rent(as % of GDP) in Caribbean small states in 1983 and the Rent(as % of GDP) in Denmark in 1984?
Keep it short and to the point. 8.3. What is the difference between the Rent(as % of GDP) in Middle East & North Africa (all income levels) in 1983 and the Rent(as % of GDP) in Middle East & North Africa (developing only) in 1984?
Ensure brevity in your answer.  8.91. What is the difference between the Rent(as % of GDP) in Middle East & North Africa (all income levels) in 1983 and the Rent(as % of GDP) in Denmark in 1984?
Your answer should be very brief. 23.37. What is the difference between the Rent(as % of GDP) in Middle East & North Africa (developing only) in 1983 and the Rent(as % of GDP) in Denmark in 1984?
Offer a terse response. 16.24. What is the difference between the Rent(as % of GDP) in Caribbean small states in 1983 and the Rent(as % of GDP) in Middle East & North Africa (all income levels) in 1985?
Make the answer very short. -10.17. What is the difference between the Rent(as % of GDP) in Caribbean small states in 1983 and the Rent(as % of GDP) in Middle East & North Africa (developing only) in 1985?
Your response must be concise. -5.19. What is the difference between the Rent(as % of GDP) of Caribbean small states in 1983 and the Rent(as % of GDP) of Denmark in 1985?
Ensure brevity in your answer.  8.22. What is the difference between the Rent(as % of GDP) in Middle East & North Africa (all income levels) in 1983 and the Rent(as % of GDP) in Middle East & North Africa (developing only) in 1985?
Offer a very short reply. 9.88. What is the difference between the Rent(as % of GDP) in Middle East & North Africa (all income levels) in 1983 and the Rent(as % of GDP) in Denmark in 1985?
Keep it short and to the point. 23.3. What is the difference between the Rent(as % of GDP) of Middle East & North Africa (developing only) in 1983 and the Rent(as % of GDP) of Denmark in 1985?
Make the answer very short. 16.17. What is the difference between the Rent(as % of GDP) of Caribbean small states in 1984 and the Rent(as % of GDP) of Middle East & North Africa (all income levels) in 1985?
Your answer should be very brief. -9.42. What is the difference between the Rent(as % of GDP) in Caribbean small states in 1984 and the Rent(as % of GDP) in Middle East & North Africa (developing only) in 1985?
Make the answer very short. -4.45. What is the difference between the Rent(as % of GDP) of Caribbean small states in 1984 and the Rent(as % of GDP) of Denmark in 1985?
Provide a succinct answer. 8.97. What is the difference between the Rent(as % of GDP) in Middle East & North Africa (all income levels) in 1984 and the Rent(as % of GDP) in Middle East & North Africa (developing only) in 1985?
Your answer should be compact. 8.15. What is the difference between the Rent(as % of GDP) in Middle East & North Africa (all income levels) in 1984 and the Rent(as % of GDP) in Denmark in 1985?
Offer a terse response. 21.57. What is the difference between the Rent(as % of GDP) of Middle East & North Africa (developing only) in 1984 and the Rent(as % of GDP) of Denmark in 1985?
Your answer should be very brief. 14.38. What is the average Rent(as % of GDP) in Caribbean small states per year?
Your answer should be compact. 12.37. What is the average Rent(as % of GDP) of Middle East & North Africa (all income levels) per year?
Your response must be concise. 31.73. What is the average Rent(as % of GDP) in Middle East & North Africa (developing only) per year?
Ensure brevity in your answer.  21.66. What is the average Rent(as % of GDP) in Denmark per year?
Your answer should be compact. 0.41. In the year 1977, what is the difference between the Rent(as % of GDP) in Caribbean small states and Rent(as % of GDP) in Middle East & North Africa (all income levels)?
Offer a terse response. -24.69. In the year 1977, what is the difference between the Rent(as % of GDP) of Caribbean small states and Rent(as % of GDP) of Middle East & North Africa (developing only)?
Offer a terse response. -16.64. In the year 1977, what is the difference between the Rent(as % of GDP) in Caribbean small states and Rent(as % of GDP) in Denmark?
Provide a succinct answer. 11.58. In the year 1977, what is the difference between the Rent(as % of GDP) of Middle East & North Africa (all income levels) and Rent(as % of GDP) of Middle East & North Africa (developing only)?
Your response must be concise. 8.05. In the year 1977, what is the difference between the Rent(as % of GDP) in Middle East & North Africa (all income levels) and Rent(as % of GDP) in Denmark?
Make the answer very short. 36.27. In the year 1977, what is the difference between the Rent(as % of GDP) of Middle East & North Africa (developing only) and Rent(as % of GDP) of Denmark?
Offer a very short reply. 28.22. In the year 1978, what is the difference between the Rent(as % of GDP) in Caribbean small states and Rent(as % of GDP) in Middle East & North Africa (all income levels)?
Offer a very short reply. -21.93. In the year 1978, what is the difference between the Rent(as % of GDP) of Caribbean small states and Rent(as % of GDP) of Middle East & North Africa (developing only)?
Ensure brevity in your answer.  -15.05. In the year 1978, what is the difference between the Rent(as % of GDP) in Caribbean small states and Rent(as % of GDP) in Denmark?
Offer a terse response. 11.72. In the year 1978, what is the difference between the Rent(as % of GDP) of Middle East & North Africa (all income levels) and Rent(as % of GDP) of Middle East & North Africa (developing only)?
Provide a succinct answer. 6.89. In the year 1978, what is the difference between the Rent(as % of GDP) of Middle East & North Africa (all income levels) and Rent(as % of GDP) of Denmark?
Give a very brief answer. 33.65. In the year 1978, what is the difference between the Rent(as % of GDP) of Middle East & North Africa (developing only) and Rent(as % of GDP) of Denmark?
Your answer should be compact. 26.76. In the year 1980, what is the difference between the Rent(as % of GDP) of Caribbean small states and Rent(as % of GDP) of Middle East & North Africa (all income levels)?
Offer a very short reply. -29.46. In the year 1980, what is the difference between the Rent(as % of GDP) in Caribbean small states and Rent(as % of GDP) in Middle East & North Africa (developing only)?
Your response must be concise. -10.68. In the year 1980, what is the difference between the Rent(as % of GDP) of Caribbean small states and Rent(as % of GDP) of Denmark?
Offer a terse response. 20.02. In the year 1980, what is the difference between the Rent(as % of GDP) in Middle East & North Africa (all income levels) and Rent(as % of GDP) in Middle East & North Africa (developing only)?
Give a very brief answer. 18.77. In the year 1980, what is the difference between the Rent(as % of GDP) of Middle East & North Africa (all income levels) and Rent(as % of GDP) of Denmark?
Keep it short and to the point. 49.48. In the year 1980, what is the difference between the Rent(as % of GDP) in Middle East & North Africa (developing only) and Rent(as % of GDP) in Denmark?
Make the answer very short. 30.7. In the year 1981, what is the difference between the Rent(as % of GDP) of Caribbean small states and Rent(as % of GDP) of Middle East & North Africa (all income levels)?
Provide a short and direct response. -23.49. In the year 1981, what is the difference between the Rent(as % of GDP) in Caribbean small states and Rent(as % of GDP) in Middle East & North Africa (developing only)?
Your answer should be very brief. -4.75. In the year 1981, what is the difference between the Rent(as % of GDP) in Caribbean small states and Rent(as % of GDP) in Denmark?
Offer a very short reply. 15.24. In the year 1981, what is the difference between the Rent(as % of GDP) of Middle East & North Africa (all income levels) and Rent(as % of GDP) of Middle East & North Africa (developing only)?
Offer a terse response. 18.74. In the year 1981, what is the difference between the Rent(as % of GDP) of Middle East & North Africa (all income levels) and Rent(as % of GDP) of Denmark?
Your answer should be compact. 38.73. In the year 1981, what is the difference between the Rent(as % of GDP) in Middle East & North Africa (developing only) and Rent(as % of GDP) in Denmark?
Make the answer very short. 19.99. In the year 1982, what is the difference between the Rent(as % of GDP) of Caribbean small states and Rent(as % of GDP) of Middle East & North Africa (all income levels)?
Make the answer very short. -17.95. In the year 1982, what is the difference between the Rent(as % of GDP) in Caribbean small states and Rent(as % of GDP) in Middle East & North Africa (developing only)?
Offer a very short reply. -9.05. In the year 1982, what is the difference between the Rent(as % of GDP) in Caribbean small states and Rent(as % of GDP) in Denmark?
Provide a short and direct response. 11.07. In the year 1982, what is the difference between the Rent(as % of GDP) in Middle East & North Africa (all income levels) and Rent(as % of GDP) in Middle East & North Africa (developing only)?
Offer a terse response. 8.9. In the year 1982, what is the difference between the Rent(as % of GDP) of Middle East & North Africa (all income levels) and Rent(as % of GDP) of Denmark?
Ensure brevity in your answer.  29.02. In the year 1982, what is the difference between the Rent(as % of GDP) of Middle East & North Africa (developing only) and Rent(as % of GDP) of Denmark?
Offer a terse response. 20.12. In the year 1983, what is the difference between the Rent(as % of GDP) of Caribbean small states and Rent(as % of GDP) of Middle East & North Africa (all income levels)?
Your answer should be compact. -15.07. In the year 1983, what is the difference between the Rent(as % of GDP) in Caribbean small states and Rent(as % of GDP) in Middle East & North Africa (developing only)?
Keep it short and to the point. -7.94. In the year 1983, what is the difference between the Rent(as % of GDP) of Caribbean small states and Rent(as % of GDP) of Denmark?
Keep it short and to the point. 8.35. In the year 1983, what is the difference between the Rent(as % of GDP) of Middle East & North Africa (all income levels) and Rent(as % of GDP) of Middle East & North Africa (developing only)?
Keep it short and to the point. 7.13. In the year 1983, what is the difference between the Rent(as % of GDP) in Middle East & North Africa (all income levels) and Rent(as % of GDP) in Denmark?
Ensure brevity in your answer.  23.42. In the year 1983, what is the difference between the Rent(as % of GDP) of Middle East & North Africa (developing only) and Rent(as % of GDP) of Denmark?
Your answer should be very brief. 16.29. In the year 1984, what is the difference between the Rent(as % of GDP) of Caribbean small states and Rent(as % of GDP) of Middle East & North Africa (all income levels)?
Keep it short and to the point. -12.59. In the year 1984, what is the difference between the Rent(as % of GDP) in Caribbean small states and Rent(as % of GDP) in Middle East & North Africa (developing only)?
Provide a short and direct response. -5.41. In the year 1984, what is the difference between the Rent(as % of GDP) in Caribbean small states and Rent(as % of GDP) in Denmark?
Your answer should be very brief. 9.04. In the year 1984, what is the difference between the Rent(as % of GDP) of Middle East & North Africa (all income levels) and Rent(as % of GDP) of Middle East & North Africa (developing only)?
Give a very brief answer. 7.18. In the year 1984, what is the difference between the Rent(as % of GDP) of Middle East & North Africa (all income levels) and Rent(as % of GDP) of Denmark?
Offer a terse response. 21.64. In the year 1984, what is the difference between the Rent(as % of GDP) in Middle East & North Africa (developing only) and Rent(as % of GDP) in Denmark?
Make the answer very short. 14.46. In the year 1985, what is the difference between the Rent(as % of GDP) in Caribbean small states and Rent(as % of GDP) in Middle East & North Africa (all income levels)?
Ensure brevity in your answer.  -9.73. In the year 1985, what is the difference between the Rent(as % of GDP) in Caribbean small states and Rent(as % of GDP) in Middle East & North Africa (developing only)?
Your answer should be very brief. -4.75. In the year 1985, what is the difference between the Rent(as % of GDP) of Caribbean small states and Rent(as % of GDP) of Denmark?
Your answer should be very brief. 8.66. In the year 1985, what is the difference between the Rent(as % of GDP) in Middle East & North Africa (all income levels) and Rent(as % of GDP) in Middle East & North Africa (developing only)?
Provide a succinct answer. 4.97. In the year 1985, what is the difference between the Rent(as % of GDP) of Middle East & North Africa (all income levels) and Rent(as % of GDP) of Denmark?
Provide a succinct answer. 18.39. In the year 1985, what is the difference between the Rent(as % of GDP) of Middle East & North Africa (developing only) and Rent(as % of GDP) of Denmark?
Give a very brief answer. 13.42. What is the ratio of the Rent(as % of GDP) of Caribbean small states in 1977 to that in 1978?
Your answer should be very brief. 0.99. What is the ratio of the Rent(as % of GDP) of Middle East & North Africa (all income levels) in 1977 to that in 1978?
Make the answer very short. 1.08. What is the ratio of the Rent(as % of GDP) of Middle East & North Africa (developing only) in 1977 to that in 1978?
Give a very brief answer. 1.06. What is the ratio of the Rent(as % of GDP) of Denmark in 1977 to that in 1978?
Your answer should be very brief. 1.48. What is the ratio of the Rent(as % of GDP) of Caribbean small states in 1977 to that in 1980?
Give a very brief answer. 0.58. What is the ratio of the Rent(as % of GDP) in Middle East & North Africa (all income levels) in 1977 to that in 1980?
Offer a terse response. 0.73. What is the ratio of the Rent(as % of GDP) of Middle East & North Africa (developing only) in 1977 to that in 1980?
Make the answer very short. 0.92. What is the ratio of the Rent(as % of GDP) of Denmark in 1977 to that in 1980?
Offer a terse response. 0.82. What is the ratio of the Rent(as % of GDP) of Caribbean small states in 1977 to that in 1981?
Keep it short and to the point. 0.75. What is the ratio of the Rent(as % of GDP) of Middle East & North Africa (all income levels) in 1977 to that in 1981?
Keep it short and to the point. 0.93. What is the ratio of the Rent(as % of GDP) in Middle East & North Africa (developing only) in 1977 to that in 1981?
Your answer should be very brief. 1.4. What is the ratio of the Rent(as % of GDP) of Denmark in 1977 to that in 1981?
Your response must be concise. 0.3. What is the ratio of the Rent(as % of GDP) of Middle East & North Africa (all income levels) in 1977 to that in 1982?
Provide a succinct answer. 1.23. What is the ratio of the Rent(as % of GDP) of Middle East & North Africa (developing only) in 1977 to that in 1982?
Your answer should be very brief. 1.37. What is the ratio of the Rent(as % of GDP) in Denmark in 1977 to that in 1982?
Offer a terse response. 0.15. What is the ratio of the Rent(as % of GDP) of Caribbean small states in 1977 to that in 1983?
Your answer should be very brief. 1.3. What is the ratio of the Rent(as % of GDP) of Middle East & North Africa (all income levels) in 1977 to that in 1983?
Your answer should be very brief. 1.51. What is the ratio of the Rent(as % of GDP) in Middle East & North Africa (developing only) in 1977 to that in 1983?
Offer a very short reply. 1.67. What is the ratio of the Rent(as % of GDP) in Denmark in 1977 to that in 1983?
Offer a terse response. 0.13. What is the ratio of the Rent(as % of GDP) of Caribbean small states in 1977 to that in 1984?
Provide a short and direct response. 1.2. What is the ratio of the Rent(as % of GDP) of Middle East & North Africa (all income levels) in 1977 to that in 1984?
Ensure brevity in your answer.  1.63. What is the ratio of the Rent(as % of GDP) of Middle East & North Africa (developing only) in 1977 to that in 1984?
Your answer should be very brief. 1.87. What is the ratio of the Rent(as % of GDP) in Denmark in 1977 to that in 1984?
Ensure brevity in your answer.  0.12. What is the ratio of the Rent(as % of GDP) in Caribbean small states in 1977 to that in 1985?
Your answer should be compact. 1.24. What is the ratio of the Rent(as % of GDP) of Middle East & North Africa (all income levels) in 1977 to that in 1985?
Offer a very short reply. 1.9. What is the ratio of the Rent(as % of GDP) in Middle East & North Africa (developing only) in 1977 to that in 1985?
Offer a very short reply. 1.99. What is the ratio of the Rent(as % of GDP) in Denmark in 1977 to that in 1985?
Your response must be concise. 0.11. What is the ratio of the Rent(as % of GDP) of Caribbean small states in 1978 to that in 1980?
Provide a succinct answer. 0.58. What is the ratio of the Rent(as % of GDP) of Middle East & North Africa (all income levels) in 1978 to that in 1980?
Provide a short and direct response. 0.68. What is the ratio of the Rent(as % of GDP) of Middle East & North Africa (developing only) in 1978 to that in 1980?
Offer a terse response. 0.87. What is the ratio of the Rent(as % of GDP) in Denmark in 1978 to that in 1980?
Give a very brief answer. 0.55. What is the ratio of the Rent(as % of GDP) of Caribbean small states in 1978 to that in 1981?
Your answer should be compact. 0.76. What is the ratio of the Rent(as % of GDP) of Middle East & North Africa (all income levels) in 1978 to that in 1981?
Your answer should be compact. 0.86. What is the ratio of the Rent(as % of GDP) of Middle East & North Africa (developing only) in 1978 to that in 1981?
Ensure brevity in your answer.  1.32. What is the ratio of the Rent(as % of GDP) of Denmark in 1978 to that in 1981?
Keep it short and to the point. 0.2. What is the ratio of the Rent(as % of GDP) in Caribbean small states in 1978 to that in 1982?
Make the answer very short. 1.01. What is the ratio of the Rent(as % of GDP) of Middle East & North Africa (all income levels) in 1978 to that in 1982?
Provide a succinct answer. 1.14. What is the ratio of the Rent(as % of GDP) of Middle East & North Africa (developing only) in 1978 to that in 1982?
Provide a short and direct response. 1.3. What is the ratio of the Rent(as % of GDP) of Denmark in 1978 to that in 1982?
Keep it short and to the point. 0.1. What is the ratio of the Rent(as % of GDP) in Caribbean small states in 1978 to that in 1983?
Your response must be concise. 1.31. What is the ratio of the Rent(as % of GDP) in Middle East & North Africa (all income levels) in 1978 to that in 1983?
Provide a short and direct response. 1.4. What is the ratio of the Rent(as % of GDP) in Middle East & North Africa (developing only) in 1978 to that in 1983?
Keep it short and to the point. 1.58. What is the ratio of the Rent(as % of GDP) in Denmark in 1978 to that in 1983?
Your answer should be very brief. 0.09. What is the ratio of the Rent(as % of GDP) of Caribbean small states in 1978 to that in 1984?
Provide a succinct answer. 1.21. What is the ratio of the Rent(as % of GDP) in Middle East & North Africa (all income levels) in 1978 to that in 1984?
Offer a very short reply. 1.51. What is the ratio of the Rent(as % of GDP) of Middle East & North Africa (developing only) in 1978 to that in 1984?
Your response must be concise. 1.77. What is the ratio of the Rent(as % of GDP) of Denmark in 1978 to that in 1984?
Offer a terse response. 0.08. What is the ratio of the Rent(as % of GDP) of Caribbean small states in 1978 to that in 1985?
Offer a very short reply. 1.25. What is the ratio of the Rent(as % of GDP) in Middle East & North Africa (all income levels) in 1978 to that in 1985?
Provide a short and direct response. 1.76. What is the ratio of the Rent(as % of GDP) of Middle East & North Africa (developing only) in 1978 to that in 1985?
Your response must be concise. 1.89. What is the ratio of the Rent(as % of GDP) in Denmark in 1978 to that in 1985?
Give a very brief answer. 0.08. What is the ratio of the Rent(as % of GDP) in Caribbean small states in 1980 to that in 1981?
Make the answer very short. 1.3. What is the ratio of the Rent(as % of GDP) of Middle East & North Africa (all income levels) in 1980 to that in 1981?
Keep it short and to the point. 1.27. What is the ratio of the Rent(as % of GDP) of Middle East & North Africa (developing only) in 1980 to that in 1981?
Keep it short and to the point. 1.52. What is the ratio of the Rent(as % of GDP) in Denmark in 1980 to that in 1981?
Provide a succinct answer. 0.37. What is the ratio of the Rent(as % of GDP) in Caribbean small states in 1980 to that in 1982?
Make the answer very short. 1.73. What is the ratio of the Rent(as % of GDP) in Middle East & North Africa (all income levels) in 1980 to that in 1982?
Make the answer very short. 1.67. What is the ratio of the Rent(as % of GDP) in Middle East & North Africa (developing only) in 1980 to that in 1982?
Provide a succinct answer. 1.49. What is the ratio of the Rent(as % of GDP) in Denmark in 1980 to that in 1982?
Provide a succinct answer. 0.18. What is the ratio of the Rent(as % of GDP) in Caribbean small states in 1980 to that in 1983?
Make the answer very short. 2.24. What is the ratio of the Rent(as % of GDP) in Middle East & North Africa (all income levels) in 1980 to that in 1983?
Offer a very short reply. 2.06. What is the ratio of the Rent(as % of GDP) in Middle East & North Africa (developing only) in 1980 to that in 1983?
Give a very brief answer. 1.82. What is the ratio of the Rent(as % of GDP) of Denmark in 1980 to that in 1983?
Provide a succinct answer. 0.16. What is the ratio of the Rent(as % of GDP) in Caribbean small states in 1980 to that in 1984?
Offer a very short reply. 2.06. What is the ratio of the Rent(as % of GDP) in Middle East & North Africa (all income levels) in 1980 to that in 1984?
Your answer should be compact. 2.22. What is the ratio of the Rent(as % of GDP) in Middle East & North Africa (developing only) in 1980 to that in 1984?
Provide a short and direct response. 2.03. What is the ratio of the Rent(as % of GDP) of Denmark in 1980 to that in 1984?
Give a very brief answer. 0.15. What is the ratio of the Rent(as % of GDP) in Caribbean small states in 1980 to that in 1985?
Offer a terse response. 2.13. What is the ratio of the Rent(as % of GDP) in Middle East & North Africa (all income levels) in 1980 to that in 1985?
Offer a terse response. 2.59. What is the ratio of the Rent(as % of GDP) in Middle East & North Africa (developing only) in 1980 to that in 1985?
Give a very brief answer. 2.17. What is the ratio of the Rent(as % of GDP) in Denmark in 1980 to that in 1985?
Offer a very short reply. 0.14. What is the ratio of the Rent(as % of GDP) of Caribbean small states in 1981 to that in 1982?
Provide a succinct answer. 1.33. What is the ratio of the Rent(as % of GDP) of Middle East & North Africa (all income levels) in 1981 to that in 1982?
Your answer should be compact. 1.32. What is the ratio of the Rent(as % of GDP) in Middle East & North Africa (developing only) in 1981 to that in 1982?
Provide a succinct answer. 0.98. What is the ratio of the Rent(as % of GDP) in Denmark in 1981 to that in 1982?
Keep it short and to the point. 0.49. What is the ratio of the Rent(as % of GDP) in Caribbean small states in 1981 to that in 1983?
Your answer should be compact. 1.72. What is the ratio of the Rent(as % of GDP) of Middle East & North Africa (all income levels) in 1981 to that in 1983?
Ensure brevity in your answer.  1.62. What is the ratio of the Rent(as % of GDP) in Middle East & North Africa (developing only) in 1981 to that in 1983?
Your response must be concise. 1.2. What is the ratio of the Rent(as % of GDP) in Denmark in 1981 to that in 1983?
Offer a terse response. 0.44. What is the ratio of the Rent(as % of GDP) in Caribbean small states in 1981 to that in 1984?
Offer a terse response. 1.59. What is the ratio of the Rent(as % of GDP) of Middle East & North Africa (all income levels) in 1981 to that in 1984?
Keep it short and to the point. 1.75. What is the ratio of the Rent(as % of GDP) of Middle East & North Africa (developing only) in 1981 to that in 1984?
Give a very brief answer. 1.34. What is the ratio of the Rent(as % of GDP) of Denmark in 1981 to that in 1984?
Provide a succinct answer. 0.41. What is the ratio of the Rent(as % of GDP) in Caribbean small states in 1981 to that in 1985?
Your answer should be very brief. 1.64. What is the ratio of the Rent(as % of GDP) in Middle East & North Africa (all income levels) in 1981 to that in 1985?
Make the answer very short. 2.03. What is the ratio of the Rent(as % of GDP) in Middle East & North Africa (developing only) in 1981 to that in 1985?
Keep it short and to the point. 1.43. What is the ratio of the Rent(as % of GDP) of Denmark in 1981 to that in 1985?
Make the answer very short. 0.37. What is the ratio of the Rent(as % of GDP) of Caribbean small states in 1982 to that in 1983?
Keep it short and to the point. 1.29. What is the ratio of the Rent(as % of GDP) of Middle East & North Africa (all income levels) in 1982 to that in 1983?
Ensure brevity in your answer.  1.23. What is the ratio of the Rent(as % of GDP) in Middle East & North Africa (developing only) in 1982 to that in 1983?
Provide a succinct answer. 1.22. What is the ratio of the Rent(as % of GDP) in Denmark in 1982 to that in 1983?
Your answer should be compact. 0.9. What is the ratio of the Rent(as % of GDP) of Caribbean small states in 1982 to that in 1984?
Ensure brevity in your answer.  1.2. What is the ratio of the Rent(as % of GDP) in Middle East & North Africa (all income levels) in 1982 to that in 1984?
Your answer should be very brief. 1.32. What is the ratio of the Rent(as % of GDP) of Middle East & North Africa (developing only) in 1982 to that in 1984?
Keep it short and to the point. 1.37. What is the ratio of the Rent(as % of GDP) in Denmark in 1982 to that in 1984?
Provide a short and direct response. 0.83. What is the ratio of the Rent(as % of GDP) in Caribbean small states in 1982 to that in 1985?
Offer a terse response. 1.23. What is the ratio of the Rent(as % of GDP) in Middle East & North Africa (all income levels) in 1982 to that in 1985?
Your answer should be very brief. 1.54. What is the ratio of the Rent(as % of GDP) in Middle East & North Africa (developing only) in 1982 to that in 1985?
Offer a very short reply. 1.46. What is the ratio of the Rent(as % of GDP) of Denmark in 1982 to that in 1985?
Ensure brevity in your answer.  0.76. What is the ratio of the Rent(as % of GDP) of Caribbean small states in 1983 to that in 1984?
Offer a very short reply. 0.92. What is the ratio of the Rent(as % of GDP) in Middle East & North Africa (all income levels) in 1983 to that in 1984?
Offer a very short reply. 1.08. What is the ratio of the Rent(as % of GDP) in Middle East & North Africa (developing only) in 1983 to that in 1984?
Your response must be concise. 1.12. What is the ratio of the Rent(as % of GDP) of Denmark in 1983 to that in 1984?
Ensure brevity in your answer.  0.93. What is the ratio of the Rent(as % of GDP) in Caribbean small states in 1983 to that in 1985?
Offer a terse response. 0.95. What is the ratio of the Rent(as % of GDP) in Middle East & North Africa (all income levels) in 1983 to that in 1985?
Provide a succinct answer. 1.26. What is the ratio of the Rent(as % of GDP) of Middle East & North Africa (developing only) in 1983 to that in 1985?
Provide a short and direct response. 1.19. What is the ratio of the Rent(as % of GDP) of Denmark in 1983 to that in 1985?
Provide a succinct answer. 0.84. What is the ratio of the Rent(as % of GDP) of Caribbean small states in 1984 to that in 1985?
Your answer should be very brief. 1.03. What is the ratio of the Rent(as % of GDP) in Middle East & North Africa (all income levels) in 1984 to that in 1985?
Offer a very short reply. 1.17. What is the ratio of the Rent(as % of GDP) of Middle East & North Africa (developing only) in 1984 to that in 1985?
Your answer should be very brief. 1.07. What is the ratio of the Rent(as % of GDP) in Denmark in 1984 to that in 1985?
Ensure brevity in your answer.  0.91. What is the difference between the highest and the second highest Rent(as % of GDP) of Caribbean small states?
Your response must be concise. 4.6. What is the difference between the highest and the second highest Rent(as % of GDP) in Middle East & North Africa (all income levels)?
Your answer should be very brief. 10.57. What is the difference between the highest and the second highest Rent(as % of GDP) in Middle East & North Africa (developing only)?
Give a very brief answer. 2.5. What is the difference between the highest and the second highest Rent(as % of GDP) in Denmark?
Your answer should be compact. 0.07. What is the difference between the highest and the lowest Rent(as % of GDP) in Caribbean small states?
Provide a succinct answer. 11.12. What is the difference between the highest and the lowest Rent(as % of GDP) in Middle East & North Africa (all income levels)?
Offer a terse response. 30.41. What is the difference between the highest and the lowest Rent(as % of GDP) in Middle East & North Africa (developing only)?
Your answer should be very brief. 16.61. What is the difference between the highest and the lowest Rent(as % of GDP) of Denmark?
Provide a succinct answer. 0.72. 